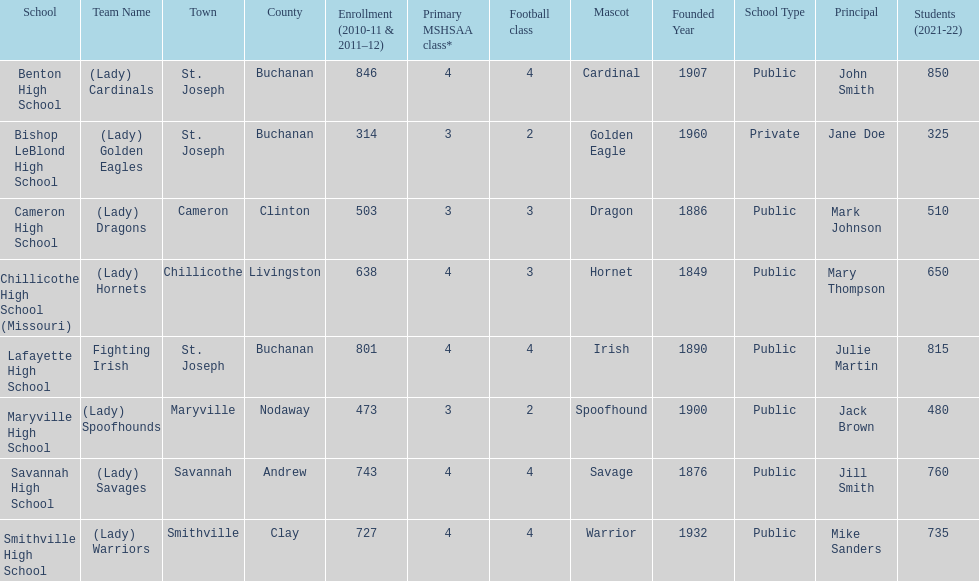Which school has the largest enrollment? Benton High School. 